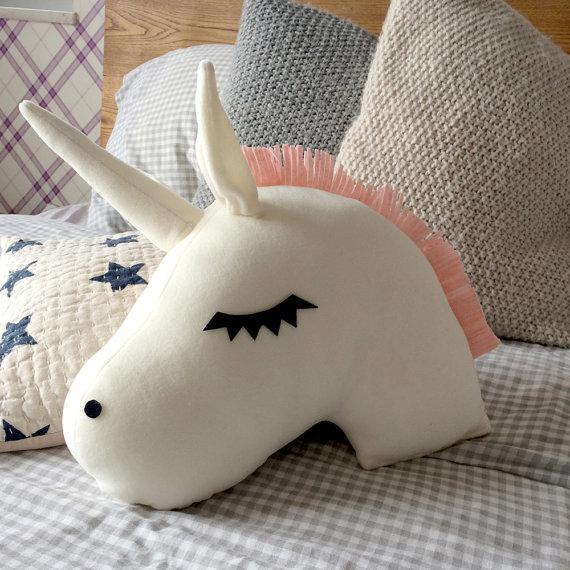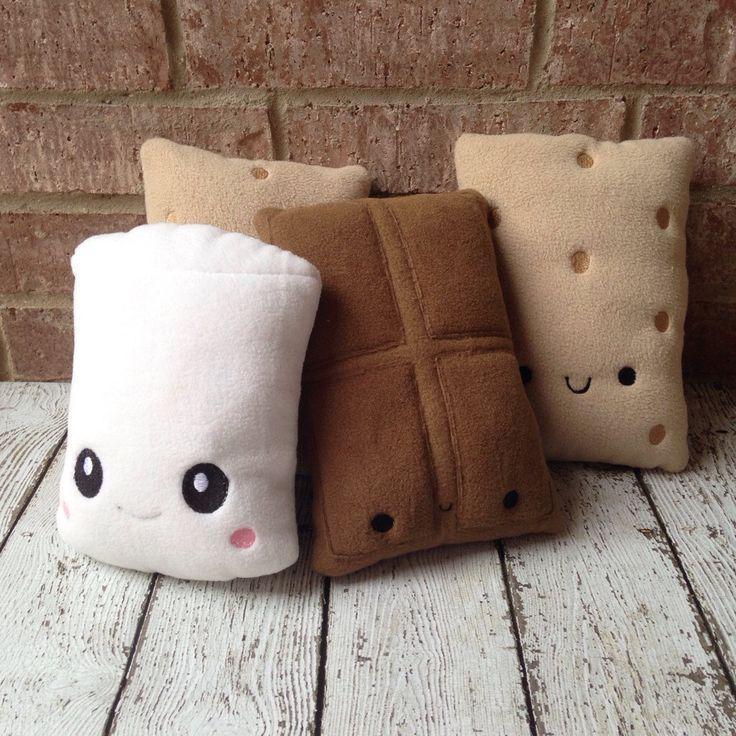The first image is the image on the left, the second image is the image on the right. Considering the images on both sides, is "An image shows one square pillow made of burlap decorated with pumpkin shapes." valid? Answer yes or no. No. The first image is the image on the left, the second image is the image on the right. Examine the images to the left and right. Is the description "A single burlap covered pillow sits on a wooden surface in the image on the left." accurate? Answer yes or no. No. 